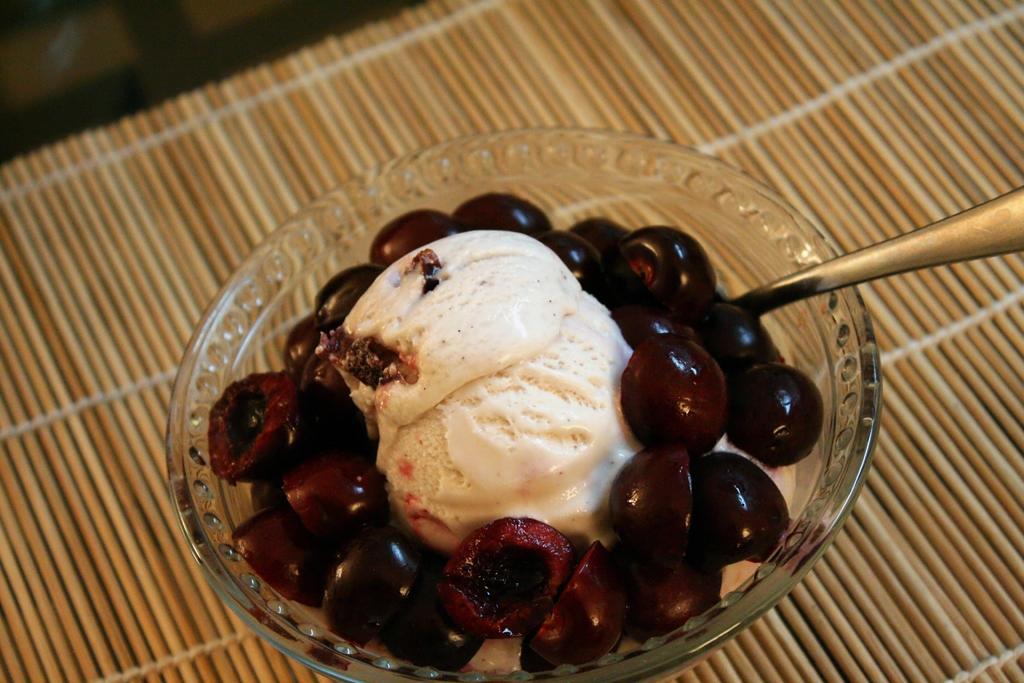Can you describe this image briefly? In this picture I can see some food item kept in a bowl along with the spoon. 